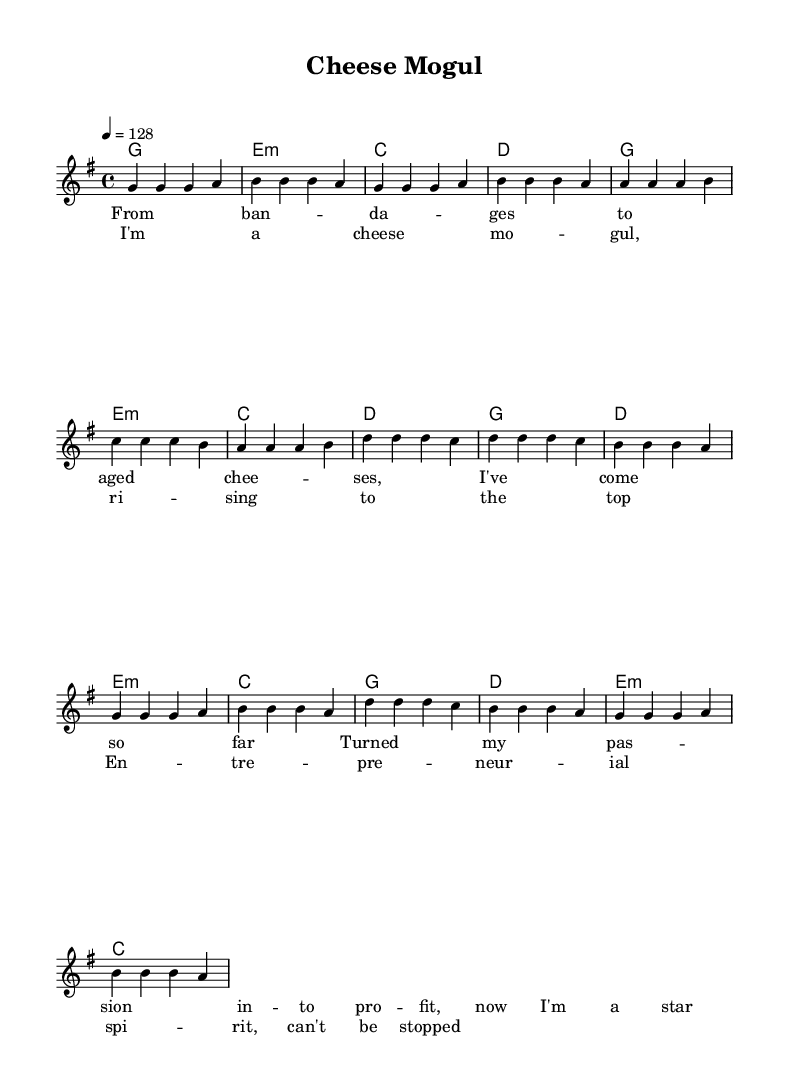What is the key signature of this music? The key signature is G major, which has one sharp (F#). This can be determined by looking at the key signature notation at the beginning of the staff.
Answer: G major What is the time signature? The time signature displayed is 4/4, indicating there are four beats in each measure and the quarter note receives one beat. This information is typically found at the beginning of the score.
Answer: 4/4 What is the tempo marking? The tempo marking is 128 beats per minute, indicated by the notation "4 = 128" at the start of the score. This shows the speed at which the piece should be played.
Answer: 128 How many measures are in the verse section? The verse section consists of 8 measures, as indicated by the layout of the music. Counting each set of bar lines, we arrive at this number.
Answer: 8 What type of dance genre is this music composed for? The genre of music is dance pop, as evidenced by the upbeat tempo and rhythmic structure that encourages movement and dancing. This can be inferred from the overall style and composition.
Answer: Dance pop What is the repeated lyrical theme in the chorus? The repeated lyrical theme in the chorus revolves around being a "cheese mogul" and the entrepreneurial spirit. This theme can be identified by examining the text of the chorus lyrics, which emphasize personal success and ambition.
Answer: Cheese mogul What is the length of each chord in the harmonies? Each chord in the harmonies is a whole note, indicated by the use of the "1" symbol under each chord's name, denoting a full measure of duration. This is observed in the chord notation throughout the harmonic progression.
Answer: Whole note 